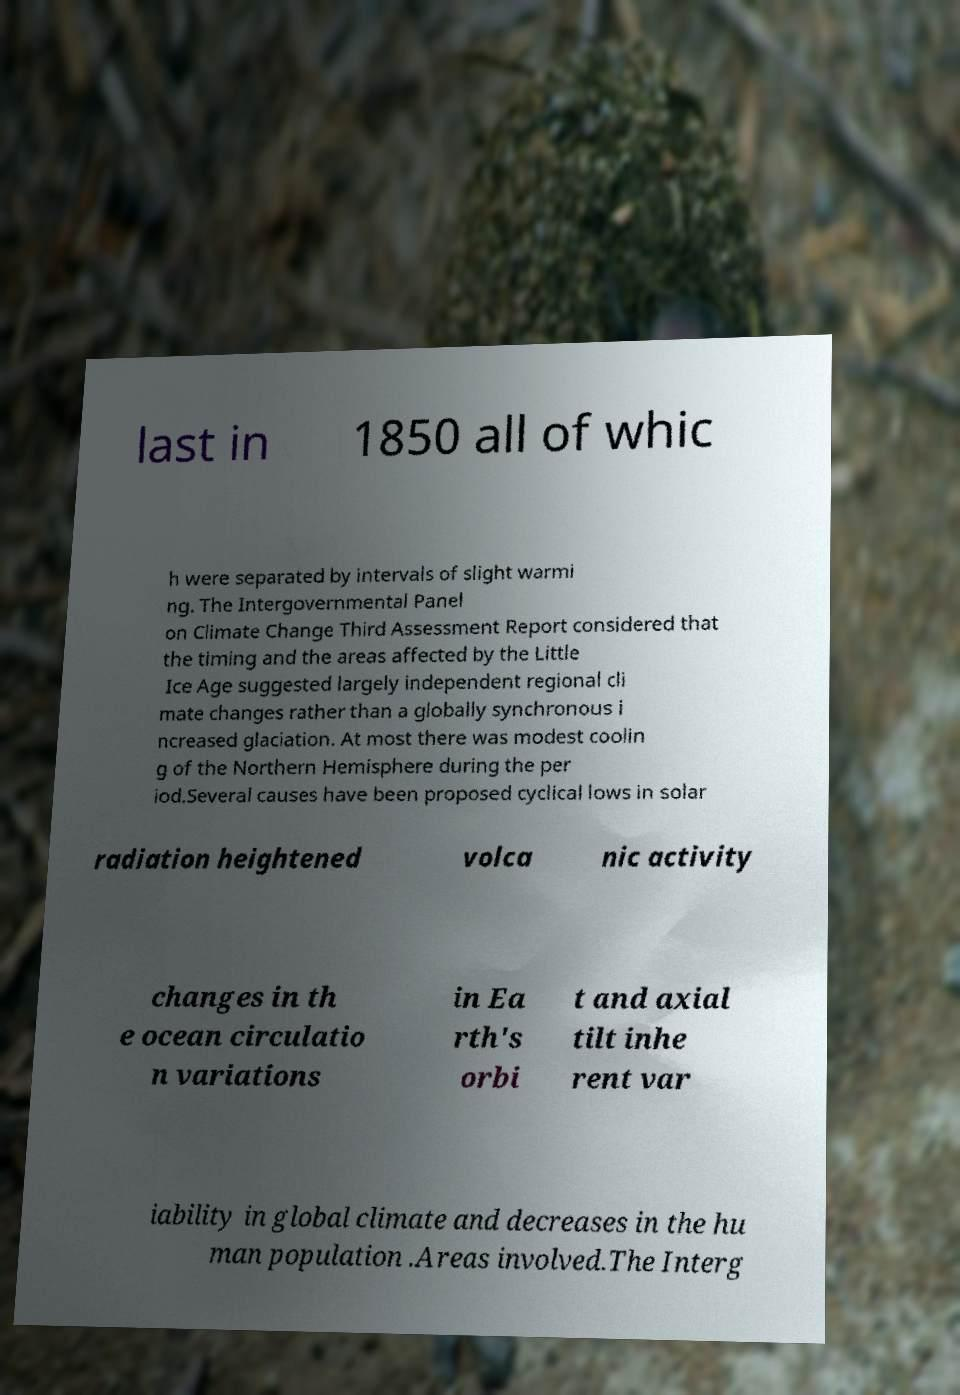I need the written content from this picture converted into text. Can you do that? last in 1850 all of whic h were separated by intervals of slight warmi ng. The Intergovernmental Panel on Climate Change Third Assessment Report considered that the timing and the areas affected by the Little Ice Age suggested largely independent regional cli mate changes rather than a globally synchronous i ncreased glaciation. At most there was modest coolin g of the Northern Hemisphere during the per iod.Several causes have been proposed cyclical lows in solar radiation heightened volca nic activity changes in th e ocean circulatio n variations in Ea rth's orbi t and axial tilt inhe rent var iability in global climate and decreases in the hu man population .Areas involved.The Interg 